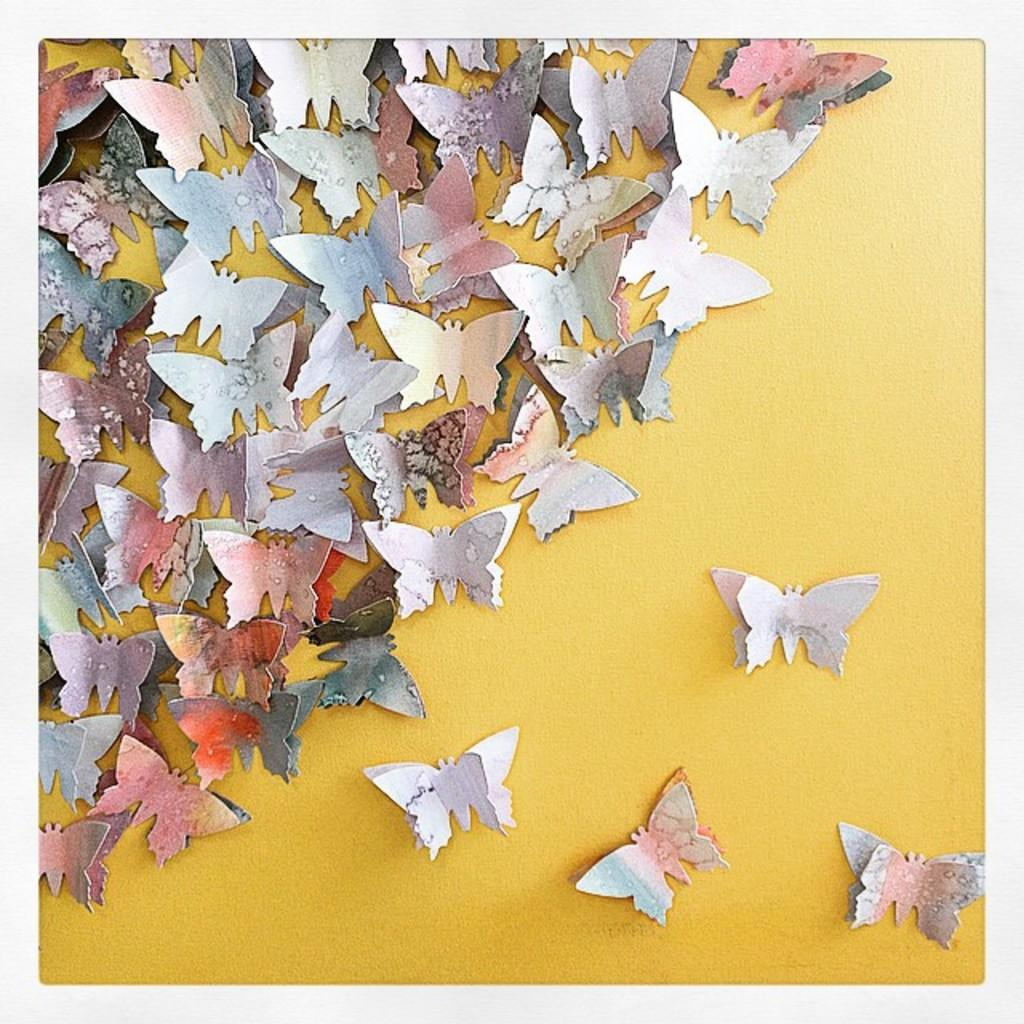What type of insects are featured in the image? There are artificial butterflies in the image. What color is the wall on which the butterflies are placed? The butterflies are on a yellow wall. What type of stew is being served in the image? There is no stew present in the image; it features artificial butterflies on a yellow wall. How many women are visible in the image? There are no women visible in the image; it only shows artificial butterflies on a yellow wall. 